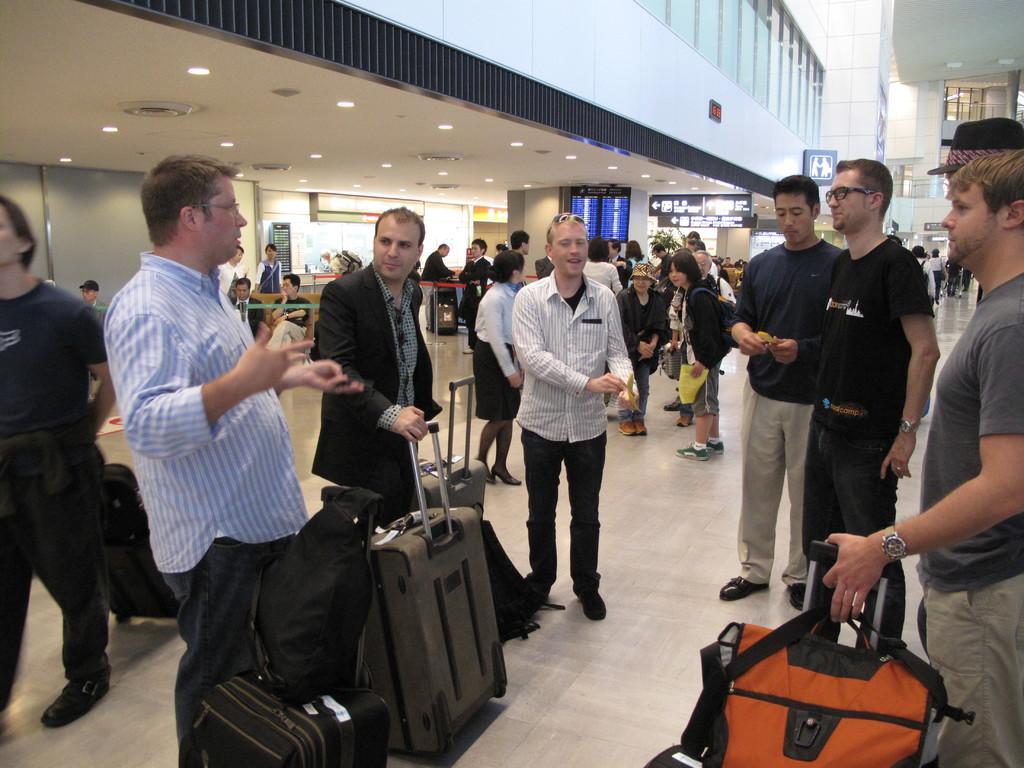In one or two sentences, can you explain what this image depicts? In this image I can see number of persons are standing on the ground and holding bags in their hands. In the background I can see the building, the ceiling, few lights to the ceiling, few boards and few other objects. 